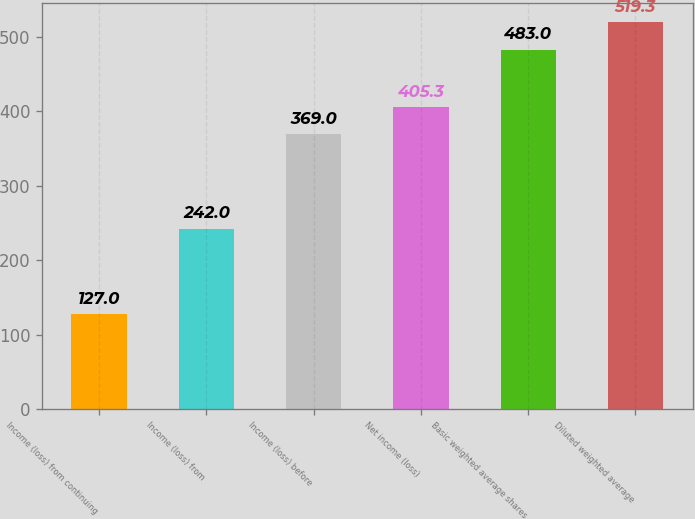Convert chart to OTSL. <chart><loc_0><loc_0><loc_500><loc_500><bar_chart><fcel>Income (loss) from continuing<fcel>Income (loss) from<fcel>Income (loss) before<fcel>Net income (loss)<fcel>Basic weighted average shares<fcel>Diluted weighted average<nl><fcel>127<fcel>242<fcel>369<fcel>405.3<fcel>483<fcel>519.3<nl></chart> 